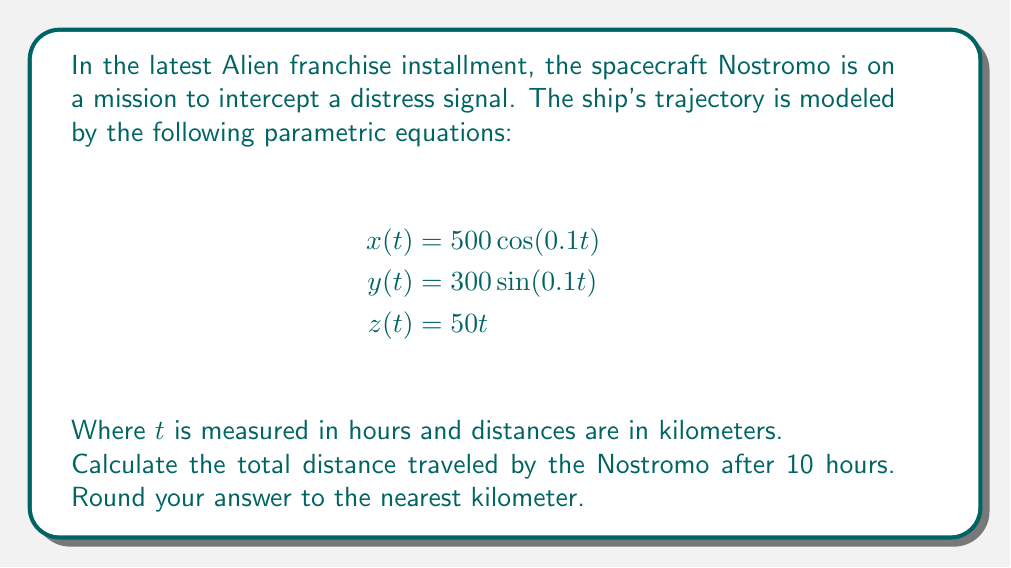Could you help me with this problem? To solve this problem, we need to follow these steps:

1) The parametric equations describe the position of the spacecraft at any given time $t$. To find the distance traveled, we need to calculate the length of the curve traced by these equations from $t=0$ to $t=10$.

2) The formula for the arc length of a parametric curve in 3D space is:

   $$L = \int_a^b \sqrt{\left(\frac{dx}{dt}\right)^2 + \left(\frac{dy}{dt}\right)^2 + \left(\frac{dz}{dt}\right)^2} dt$$

3) First, let's find the derivatives:
   
   $$\frac{dx}{dt} = -50\sin(0.1t)$$
   $$\frac{dy}{dt} = 30\cos(0.1t)$$
   $$\frac{dz}{dt} = 50$$

4) Now, let's substitute these into our arc length formula:

   $$L = \int_0^{10} \sqrt{(-50\sin(0.1t))^2 + (30\cos(0.1t))^2 + 50^2} dt$$

5) Simplify under the square root:

   $$L = \int_0^{10} \sqrt{2500\sin^2(0.1t) + 900\cos^2(0.1t) + 2500} dt$$

6) Using the trigonometric identity $\sin^2(x) + \cos^2(x) = 1$, we can simplify further:

   $$L = \int_0^{10} \sqrt{2500(\sin^2(0.1t) + \cos^2(0.1t)) + 900\cos^2(0.1t) + 2500} dt$$
   $$L = \int_0^{10} \sqrt{2500 + 900\cos^2(0.1t) + 2500} dt$$
   $$L = \int_0^{10} \sqrt{5000 + 900\cos^2(0.1t)} dt$$

7) This integral doesn't have a simple analytical solution, so we need to use numerical integration methods. Using a computer algebra system or numerical integration calculator, we get:

   $$L \approx 707.1068$$

8) Rounding to the nearest kilometer:

   $$L \approx 707 \text{ km}$$
Answer: 707 km 